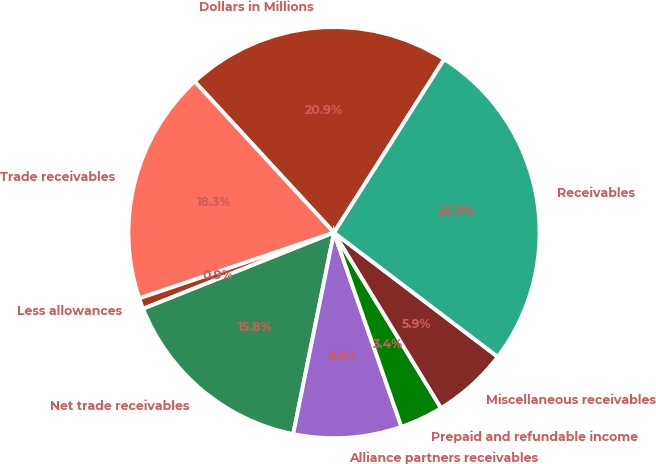<chart> <loc_0><loc_0><loc_500><loc_500><pie_chart><fcel>Dollars in Millions<fcel>Trade receivables<fcel>Less allowances<fcel>Net trade receivables<fcel>Alliance partners receivables<fcel>Prepaid and refundable income<fcel>Miscellaneous receivables<fcel>Receivables<nl><fcel>20.87%<fcel>18.33%<fcel>0.86%<fcel>15.78%<fcel>8.5%<fcel>3.4%<fcel>5.95%<fcel>26.32%<nl></chart> 